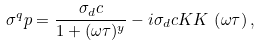Convert formula to latex. <formula><loc_0><loc_0><loc_500><loc_500>\sigma ^ { q } p = \frac { \sigma _ { d } c } { 1 + ( \omega \tau ) ^ { y } } - i \sigma _ { d } c K K \, \left ( \omega \tau \right ) ,</formula> 